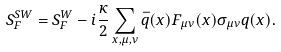Convert formula to latex. <formula><loc_0><loc_0><loc_500><loc_500>S _ { F } ^ { S W } = S _ { F } ^ { W } - i \frac { \kappa } { 2 } \sum _ { x , \mu , \nu } \bar { q } ( x ) F _ { \mu \nu } ( x ) \sigma _ { \mu \nu } q ( x ) .</formula> 